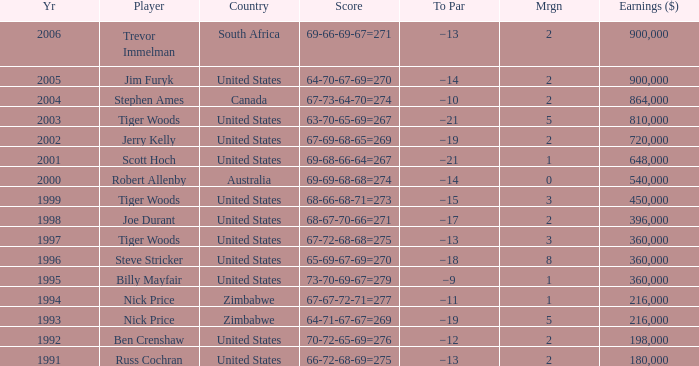What is russ cochran's average margin? 2.0. 